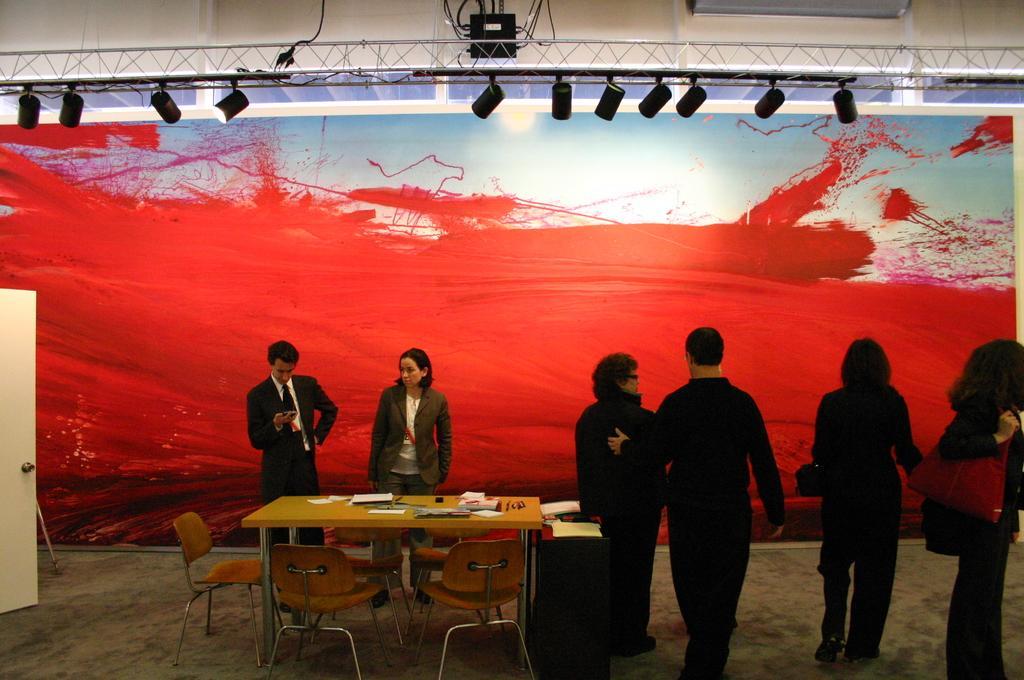Please provide a concise description of this image. this picture shows few people standing and a person holding a mobile in his hand and we see a table and few chairs and some papers on the table and we see a woman holding a handbag in her hand. 